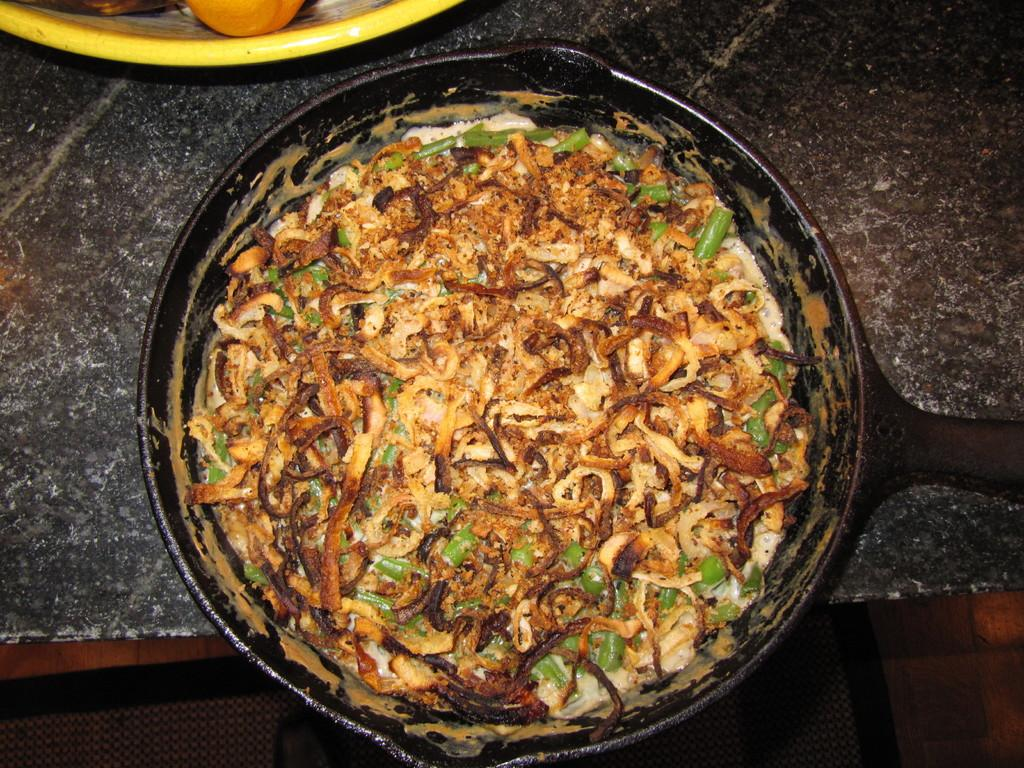What animal is present in the image? There is a weasel in the image. What is inside the weasel? The weasel contains food items. What is the object with fruits on it in the image? There is a bow in the image, and it has fruits on it. Where are the weasel and bow located? The weasel and bow are placed on a table. What type of collar can be seen on the weasel in the image? There is no collar present on the weasel in the image. How many servings of oatmeal are visible in the image? There is no oatmeal present in the image. 